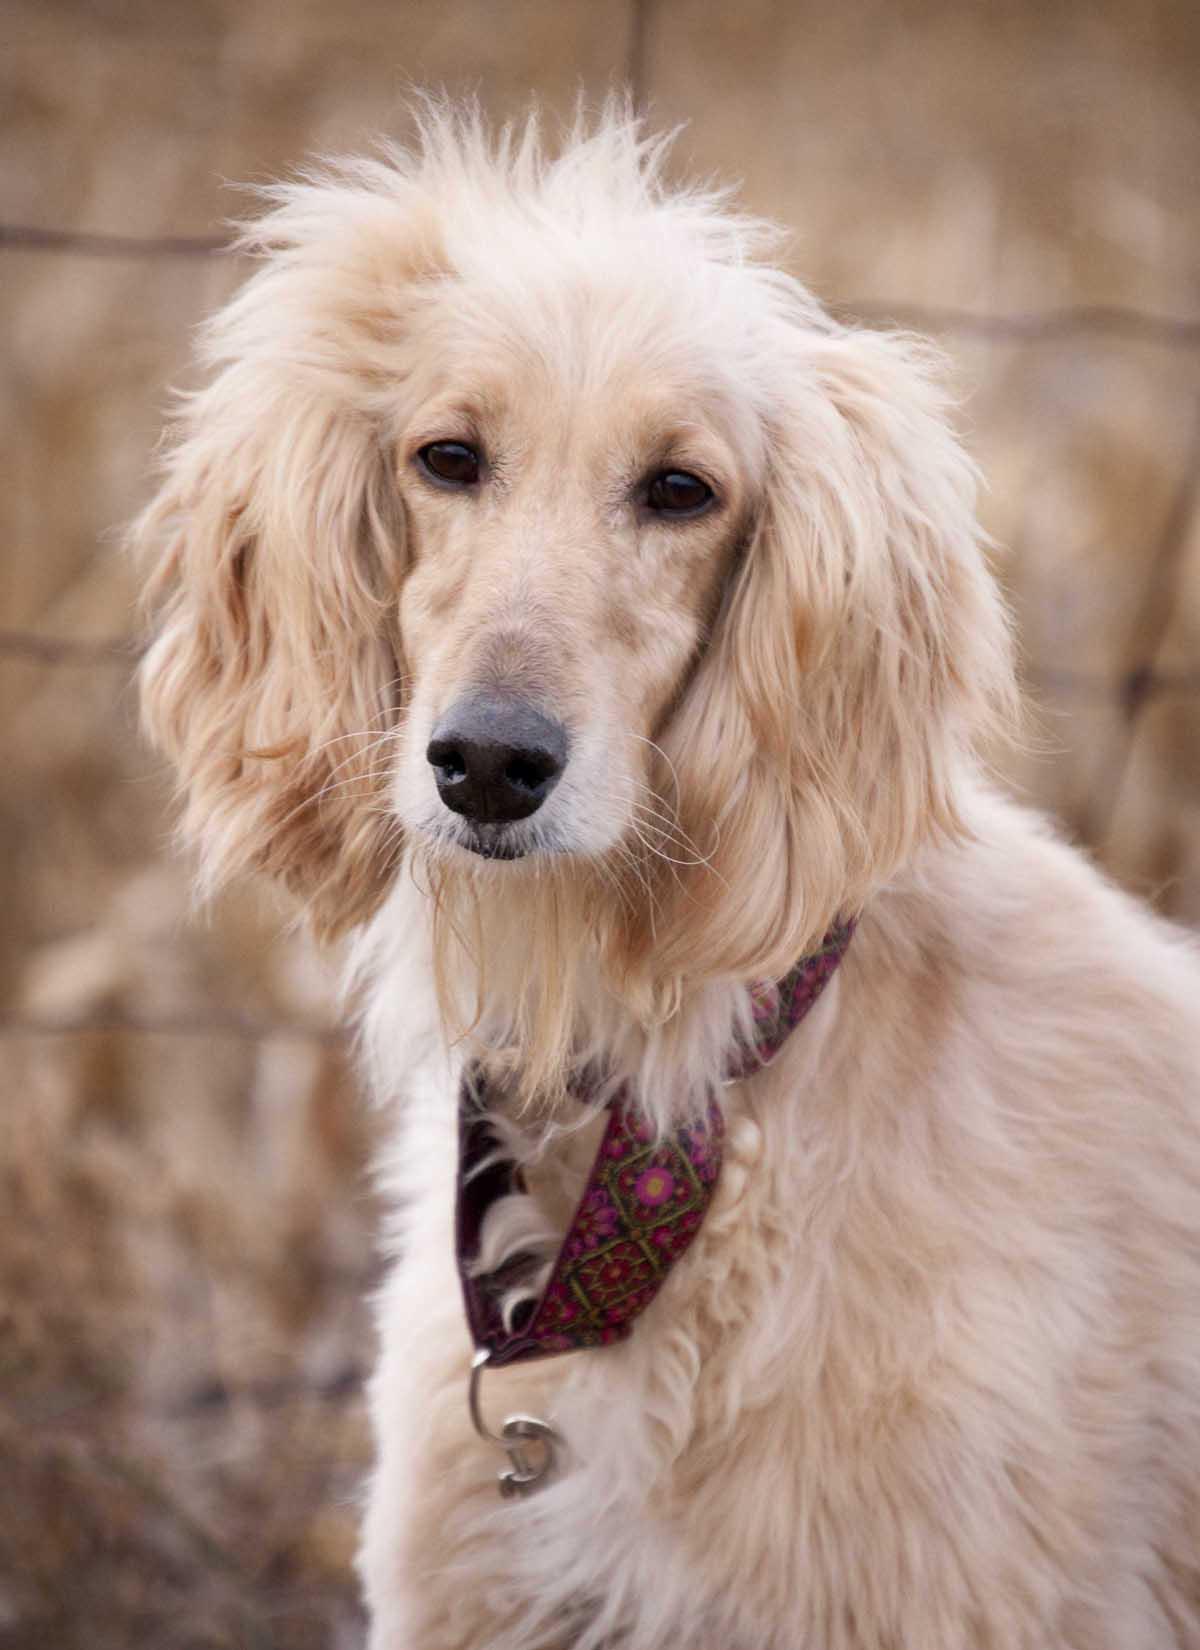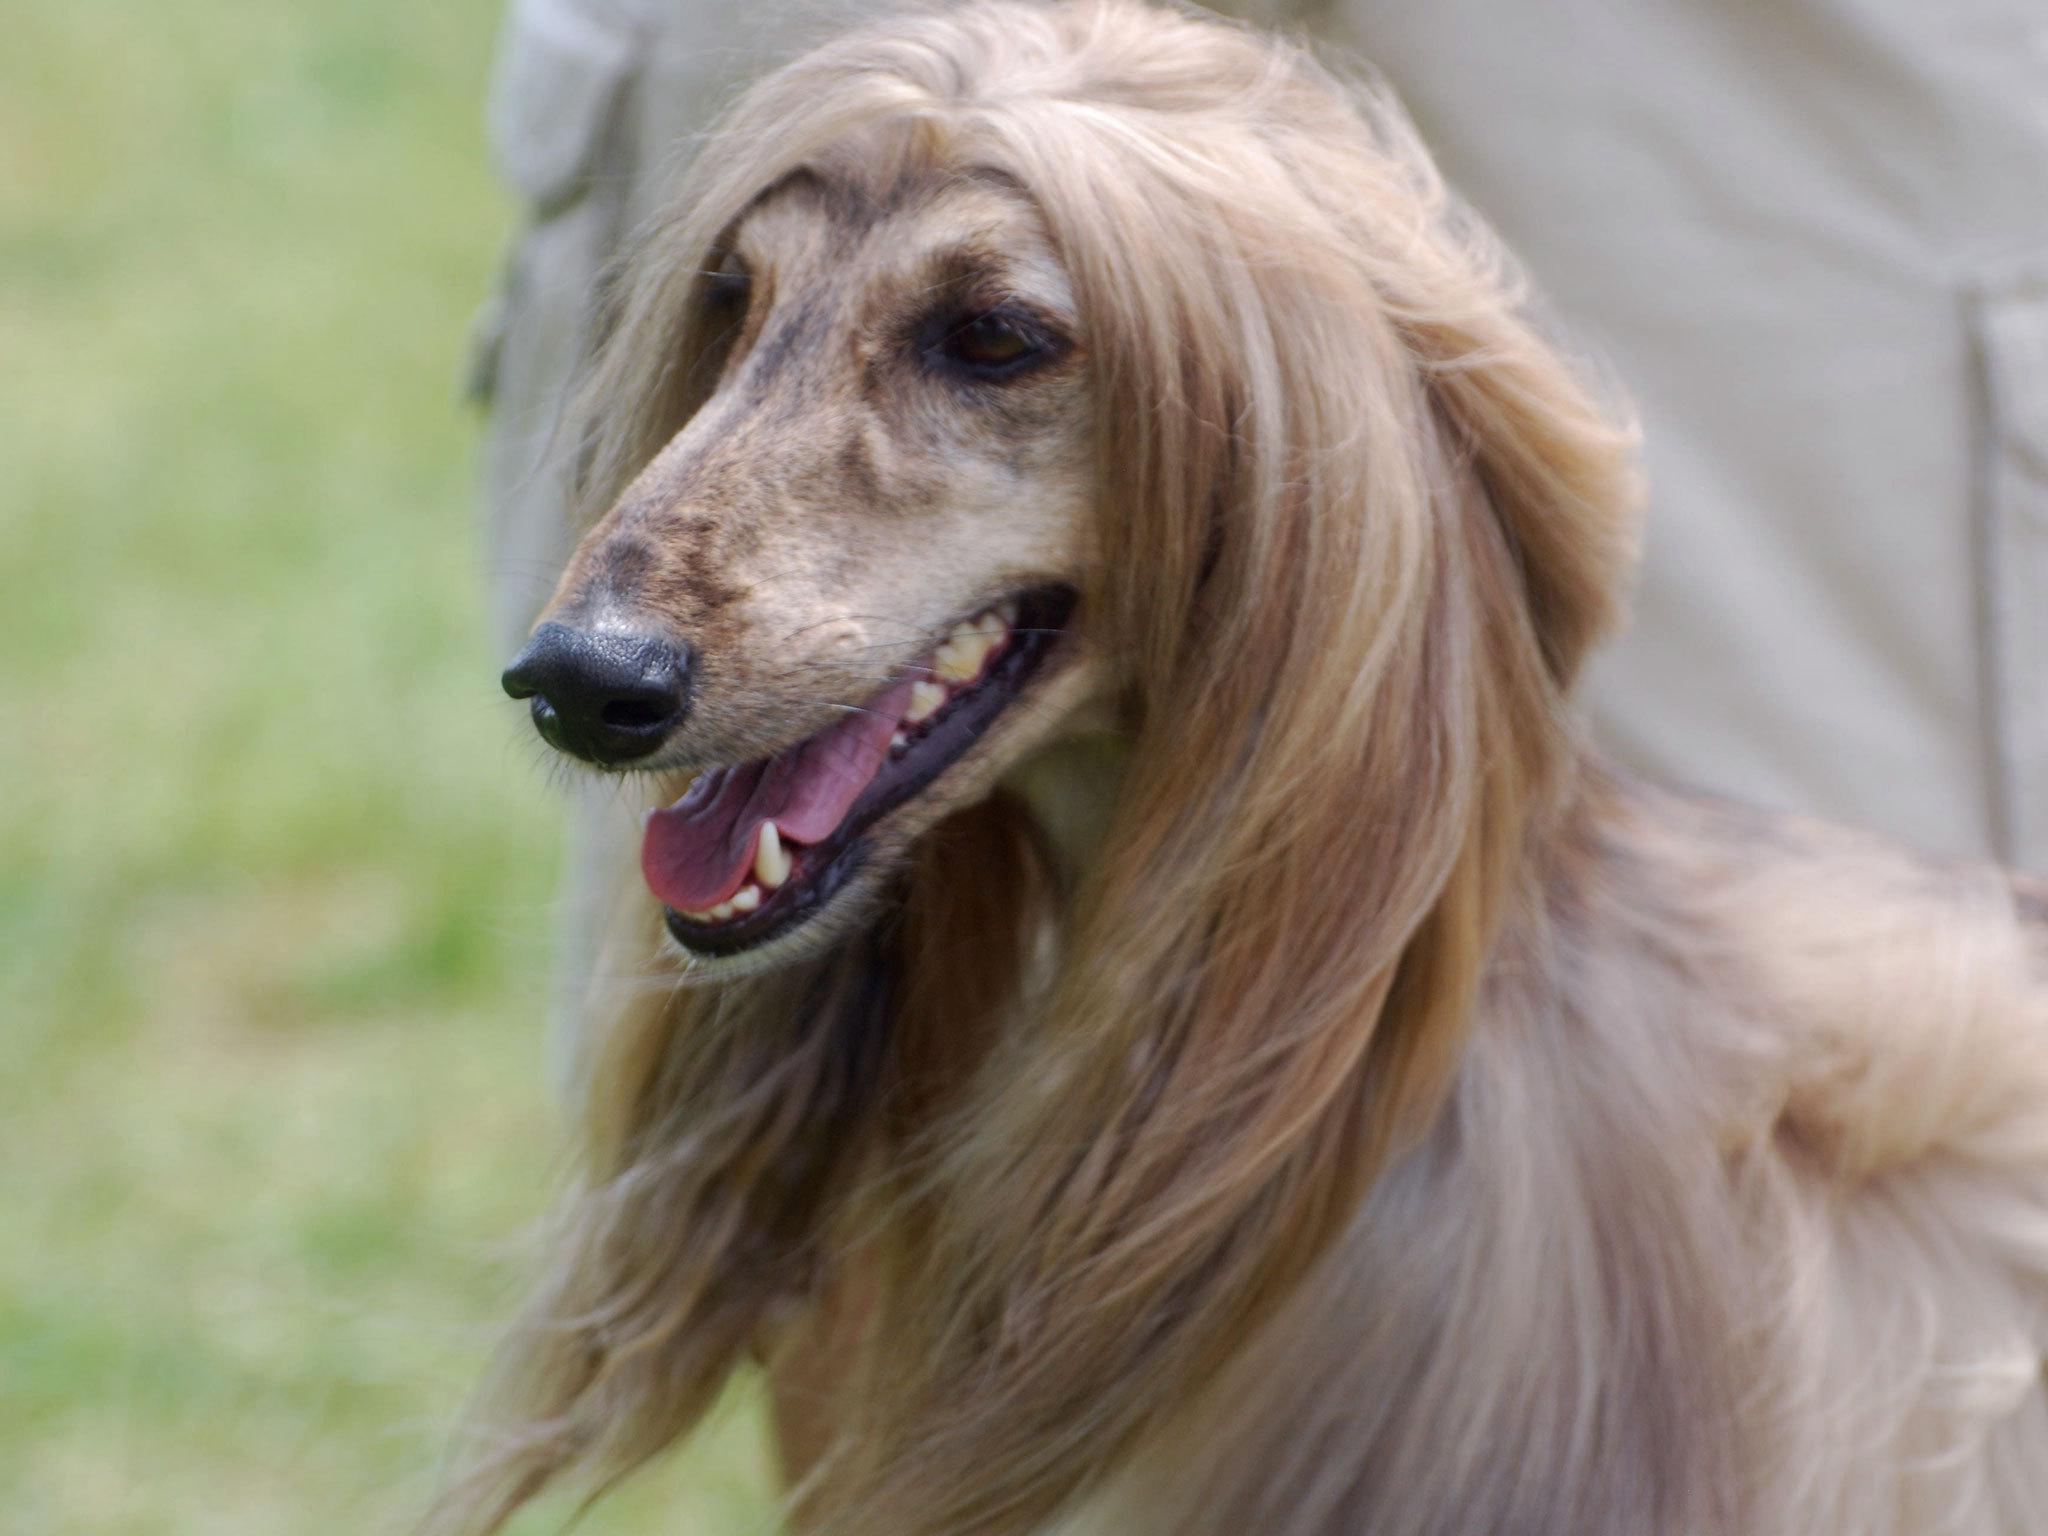The first image is the image on the left, the second image is the image on the right. For the images shown, is this caption "One image features at least two dogs." true? Answer yes or no. No. 